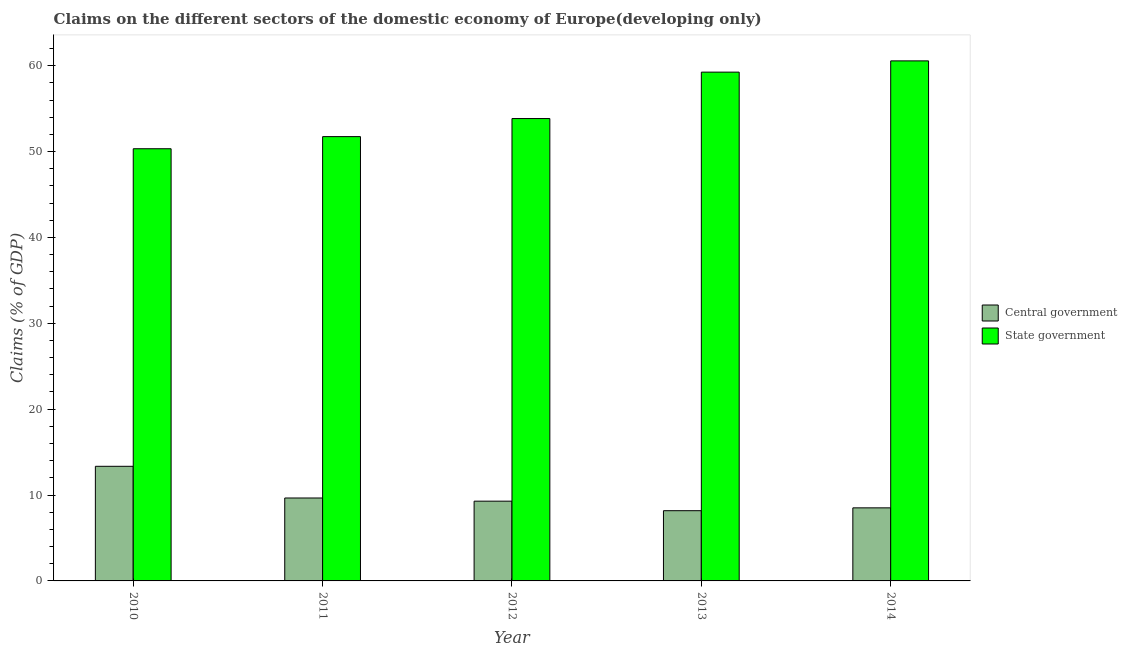How many groups of bars are there?
Your answer should be compact. 5. Are the number of bars per tick equal to the number of legend labels?
Offer a very short reply. Yes. Are the number of bars on each tick of the X-axis equal?
Your response must be concise. Yes. How many bars are there on the 3rd tick from the left?
Provide a succinct answer. 2. What is the label of the 1st group of bars from the left?
Your answer should be very brief. 2010. What is the claims on central government in 2011?
Your answer should be compact. 9.66. Across all years, what is the maximum claims on central government?
Offer a terse response. 13.35. Across all years, what is the minimum claims on central government?
Provide a succinct answer. 8.18. In which year was the claims on state government minimum?
Offer a very short reply. 2010. What is the total claims on central government in the graph?
Make the answer very short. 48.98. What is the difference between the claims on central government in 2010 and that in 2013?
Ensure brevity in your answer.  5.17. What is the difference between the claims on central government in 2011 and the claims on state government in 2010?
Your answer should be compact. -3.69. What is the average claims on state government per year?
Give a very brief answer. 55.14. In the year 2011, what is the difference between the claims on central government and claims on state government?
Give a very brief answer. 0. What is the ratio of the claims on central government in 2011 to that in 2013?
Offer a very short reply. 1.18. Is the claims on central government in 2012 less than that in 2014?
Your response must be concise. No. Is the difference between the claims on state government in 2011 and 2012 greater than the difference between the claims on central government in 2011 and 2012?
Your answer should be compact. No. What is the difference between the highest and the second highest claims on state government?
Provide a succinct answer. 1.31. What is the difference between the highest and the lowest claims on state government?
Your answer should be very brief. 10.23. What does the 1st bar from the left in 2012 represents?
Provide a short and direct response. Central government. What does the 2nd bar from the right in 2012 represents?
Provide a succinct answer. Central government. Are all the bars in the graph horizontal?
Give a very brief answer. No. Are the values on the major ticks of Y-axis written in scientific E-notation?
Offer a very short reply. No. Does the graph contain grids?
Keep it short and to the point. No. How many legend labels are there?
Ensure brevity in your answer.  2. What is the title of the graph?
Ensure brevity in your answer.  Claims on the different sectors of the domestic economy of Europe(developing only). What is the label or title of the Y-axis?
Keep it short and to the point. Claims (% of GDP). What is the Claims (% of GDP) of Central government in 2010?
Your response must be concise. 13.35. What is the Claims (% of GDP) in State government in 2010?
Give a very brief answer. 50.33. What is the Claims (% of GDP) of Central government in 2011?
Offer a very short reply. 9.66. What is the Claims (% of GDP) of State government in 2011?
Keep it short and to the point. 51.74. What is the Claims (% of GDP) of Central government in 2012?
Your answer should be compact. 9.29. What is the Claims (% of GDP) in State government in 2012?
Offer a terse response. 53.84. What is the Claims (% of GDP) of Central government in 2013?
Offer a very short reply. 8.18. What is the Claims (% of GDP) of State government in 2013?
Ensure brevity in your answer.  59.25. What is the Claims (% of GDP) in Central government in 2014?
Offer a very short reply. 8.51. What is the Claims (% of GDP) of State government in 2014?
Your answer should be compact. 60.56. Across all years, what is the maximum Claims (% of GDP) of Central government?
Offer a very short reply. 13.35. Across all years, what is the maximum Claims (% of GDP) of State government?
Ensure brevity in your answer.  60.56. Across all years, what is the minimum Claims (% of GDP) of Central government?
Offer a terse response. 8.18. Across all years, what is the minimum Claims (% of GDP) of State government?
Your response must be concise. 50.33. What is the total Claims (% of GDP) in Central government in the graph?
Make the answer very short. 48.98. What is the total Claims (% of GDP) of State government in the graph?
Your answer should be very brief. 275.71. What is the difference between the Claims (% of GDP) in Central government in 2010 and that in 2011?
Offer a very short reply. 3.69. What is the difference between the Claims (% of GDP) in State government in 2010 and that in 2011?
Offer a very short reply. -1.41. What is the difference between the Claims (% of GDP) of Central government in 2010 and that in 2012?
Offer a very short reply. 4.06. What is the difference between the Claims (% of GDP) in State government in 2010 and that in 2012?
Ensure brevity in your answer.  -3.51. What is the difference between the Claims (% of GDP) of Central government in 2010 and that in 2013?
Keep it short and to the point. 5.17. What is the difference between the Claims (% of GDP) of State government in 2010 and that in 2013?
Offer a very short reply. -8.92. What is the difference between the Claims (% of GDP) in Central government in 2010 and that in 2014?
Your answer should be very brief. 4.84. What is the difference between the Claims (% of GDP) of State government in 2010 and that in 2014?
Offer a very short reply. -10.23. What is the difference between the Claims (% of GDP) in Central government in 2011 and that in 2012?
Your response must be concise. 0.37. What is the difference between the Claims (% of GDP) of State government in 2011 and that in 2012?
Your answer should be compact. -2.1. What is the difference between the Claims (% of GDP) of Central government in 2011 and that in 2013?
Your answer should be compact. 1.48. What is the difference between the Claims (% of GDP) of State government in 2011 and that in 2013?
Make the answer very short. -7.51. What is the difference between the Claims (% of GDP) in Central government in 2011 and that in 2014?
Offer a terse response. 1.15. What is the difference between the Claims (% of GDP) of State government in 2011 and that in 2014?
Make the answer very short. -8.82. What is the difference between the Claims (% of GDP) in Central government in 2012 and that in 2013?
Make the answer very short. 1.11. What is the difference between the Claims (% of GDP) of State government in 2012 and that in 2013?
Provide a succinct answer. -5.41. What is the difference between the Claims (% of GDP) of Central government in 2012 and that in 2014?
Offer a terse response. 0.78. What is the difference between the Claims (% of GDP) in State government in 2012 and that in 2014?
Keep it short and to the point. -6.72. What is the difference between the Claims (% of GDP) in Central government in 2013 and that in 2014?
Offer a terse response. -0.33. What is the difference between the Claims (% of GDP) in State government in 2013 and that in 2014?
Give a very brief answer. -1.31. What is the difference between the Claims (% of GDP) of Central government in 2010 and the Claims (% of GDP) of State government in 2011?
Offer a very short reply. -38.39. What is the difference between the Claims (% of GDP) in Central government in 2010 and the Claims (% of GDP) in State government in 2012?
Your response must be concise. -40.49. What is the difference between the Claims (% of GDP) of Central government in 2010 and the Claims (% of GDP) of State government in 2013?
Give a very brief answer. -45.9. What is the difference between the Claims (% of GDP) of Central government in 2010 and the Claims (% of GDP) of State government in 2014?
Keep it short and to the point. -47.21. What is the difference between the Claims (% of GDP) of Central government in 2011 and the Claims (% of GDP) of State government in 2012?
Offer a terse response. -44.18. What is the difference between the Claims (% of GDP) in Central government in 2011 and the Claims (% of GDP) in State government in 2013?
Your answer should be compact. -49.59. What is the difference between the Claims (% of GDP) in Central government in 2011 and the Claims (% of GDP) in State government in 2014?
Keep it short and to the point. -50.9. What is the difference between the Claims (% of GDP) of Central government in 2012 and the Claims (% of GDP) of State government in 2013?
Your response must be concise. -49.96. What is the difference between the Claims (% of GDP) in Central government in 2012 and the Claims (% of GDP) in State government in 2014?
Provide a short and direct response. -51.27. What is the difference between the Claims (% of GDP) in Central government in 2013 and the Claims (% of GDP) in State government in 2014?
Your response must be concise. -52.38. What is the average Claims (% of GDP) in Central government per year?
Keep it short and to the point. 9.8. What is the average Claims (% of GDP) in State government per year?
Provide a short and direct response. 55.14. In the year 2010, what is the difference between the Claims (% of GDP) of Central government and Claims (% of GDP) of State government?
Offer a terse response. -36.98. In the year 2011, what is the difference between the Claims (% of GDP) of Central government and Claims (% of GDP) of State government?
Your answer should be compact. -42.08. In the year 2012, what is the difference between the Claims (% of GDP) of Central government and Claims (% of GDP) of State government?
Ensure brevity in your answer.  -44.55. In the year 2013, what is the difference between the Claims (% of GDP) of Central government and Claims (% of GDP) of State government?
Offer a very short reply. -51.07. In the year 2014, what is the difference between the Claims (% of GDP) in Central government and Claims (% of GDP) in State government?
Give a very brief answer. -52.05. What is the ratio of the Claims (% of GDP) of Central government in 2010 to that in 2011?
Offer a very short reply. 1.38. What is the ratio of the Claims (% of GDP) of State government in 2010 to that in 2011?
Give a very brief answer. 0.97. What is the ratio of the Claims (% of GDP) of Central government in 2010 to that in 2012?
Keep it short and to the point. 1.44. What is the ratio of the Claims (% of GDP) in State government in 2010 to that in 2012?
Your answer should be very brief. 0.93. What is the ratio of the Claims (% of GDP) of Central government in 2010 to that in 2013?
Offer a very short reply. 1.63. What is the ratio of the Claims (% of GDP) of State government in 2010 to that in 2013?
Your response must be concise. 0.85. What is the ratio of the Claims (% of GDP) of Central government in 2010 to that in 2014?
Provide a succinct answer. 1.57. What is the ratio of the Claims (% of GDP) of State government in 2010 to that in 2014?
Offer a terse response. 0.83. What is the ratio of the Claims (% of GDP) in Central government in 2011 to that in 2012?
Ensure brevity in your answer.  1.04. What is the ratio of the Claims (% of GDP) of State government in 2011 to that in 2012?
Ensure brevity in your answer.  0.96. What is the ratio of the Claims (% of GDP) of Central government in 2011 to that in 2013?
Keep it short and to the point. 1.18. What is the ratio of the Claims (% of GDP) in State government in 2011 to that in 2013?
Your answer should be compact. 0.87. What is the ratio of the Claims (% of GDP) of Central government in 2011 to that in 2014?
Keep it short and to the point. 1.13. What is the ratio of the Claims (% of GDP) of State government in 2011 to that in 2014?
Offer a terse response. 0.85. What is the ratio of the Claims (% of GDP) of Central government in 2012 to that in 2013?
Provide a succinct answer. 1.14. What is the ratio of the Claims (% of GDP) in State government in 2012 to that in 2013?
Make the answer very short. 0.91. What is the ratio of the Claims (% of GDP) in Central government in 2012 to that in 2014?
Provide a succinct answer. 1.09. What is the ratio of the Claims (% of GDP) of State government in 2012 to that in 2014?
Your answer should be compact. 0.89. What is the ratio of the Claims (% of GDP) of Central government in 2013 to that in 2014?
Keep it short and to the point. 0.96. What is the ratio of the Claims (% of GDP) in State government in 2013 to that in 2014?
Make the answer very short. 0.98. What is the difference between the highest and the second highest Claims (% of GDP) of Central government?
Provide a short and direct response. 3.69. What is the difference between the highest and the second highest Claims (% of GDP) of State government?
Your answer should be very brief. 1.31. What is the difference between the highest and the lowest Claims (% of GDP) of Central government?
Ensure brevity in your answer.  5.17. What is the difference between the highest and the lowest Claims (% of GDP) of State government?
Your answer should be compact. 10.23. 